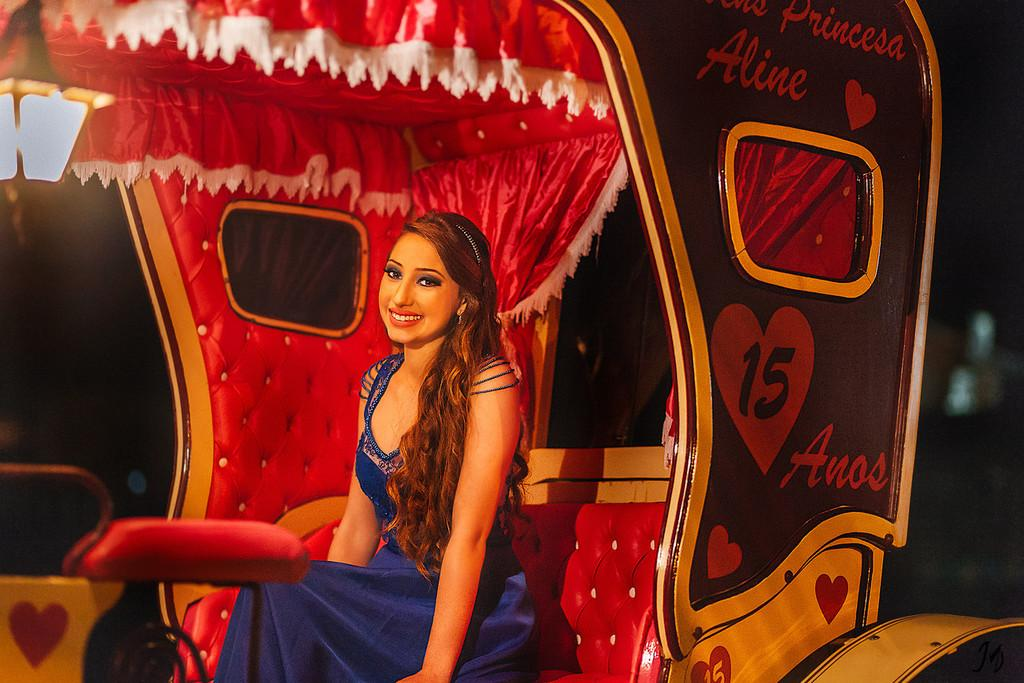Who is the main subject in the image? There is a woman in the image. What is the woman doing in the image? The woman is sitting in a rickshaw. What can be observed about the background of the image? The background of the image is dark. What type of impulse can be seen affecting the woman's clam in the image? There is no clam or impulse present in the image; it features a woman sitting in a rickshaw with a dark background. How does the woman's knee contribute to the overall composition of the image? There is no mention of the woman's knee in the image, so it cannot be determined how it contributes to the composition. 